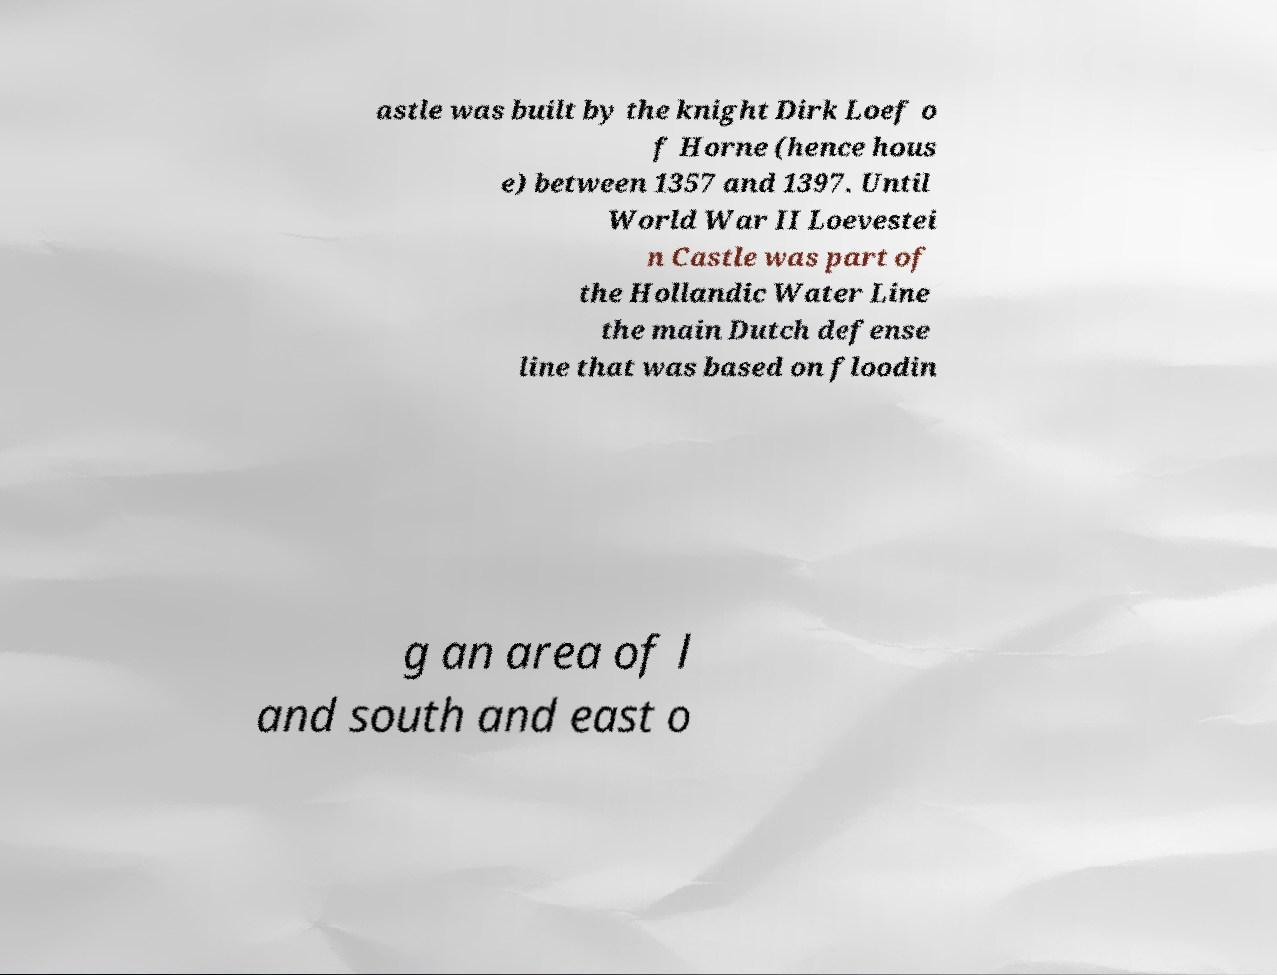Please identify and transcribe the text found in this image. astle was built by the knight Dirk Loef o f Horne (hence hous e) between 1357 and 1397. Until World War II Loevestei n Castle was part of the Hollandic Water Line the main Dutch defense line that was based on floodin g an area of l and south and east o 